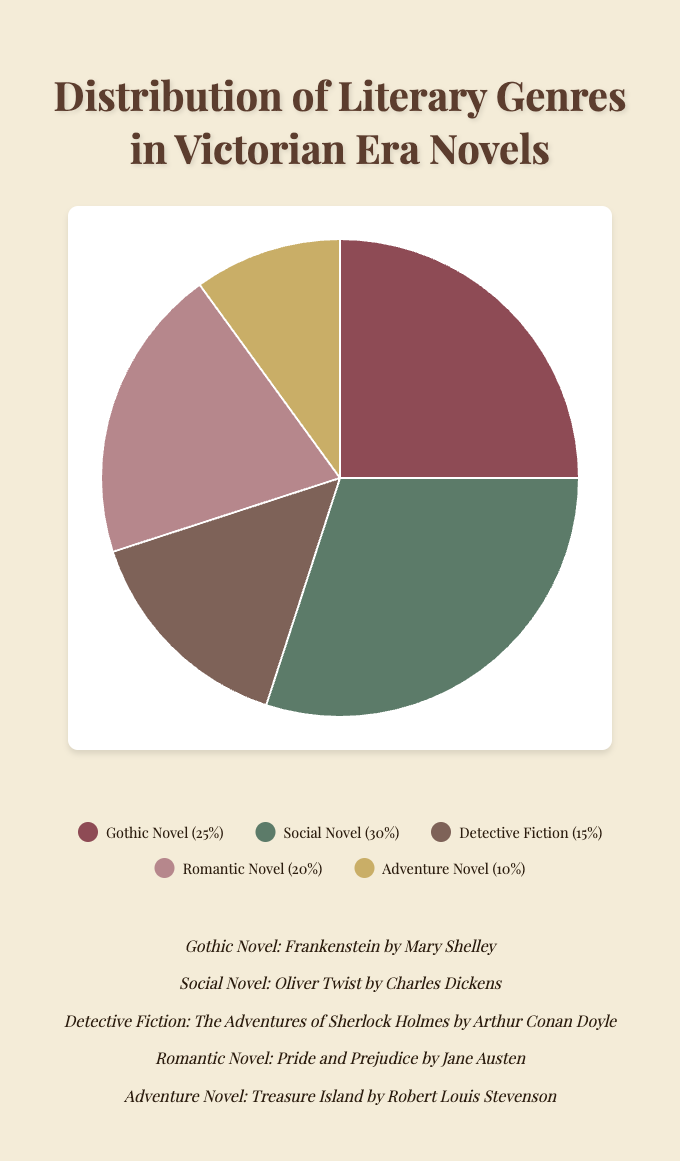What's the most predominant literary genre in the Victorian era according to the chart? Inspecting the pie chart, the largest slice corresponds to the Social Novel, indicating it is the most predominant genre.
Answer: Social Novel Which genre has the smallest representation in the chart, and what percentage does it hold? The smallest section of the pie chart represents the Adventure Novel, holding 10%.
Answer: Adventure Novel, 10% Combine the percentages of Gothic and Romantic Novels. What do they sum to? Adding the percentage of the Gothic Novel (25%) and the Romantic Novel (20%) results in 45%.
Answer: 45% How much greater is the representation of Social Novels compared to Detective Fiction? The Social Novel constitutes 30%, while Detective Fiction is at 15%. The difference can be calculated as 30% - 15% = 15%.
Answer: 15% Rank the genres from most to least represented according to the chart. From most to least: Social Novel (30%), Gothic Novel (25%), Romantic Novel (20%), Detective Fiction (15%), Adventure Novel (10%).
Answer: Social Novel, Gothic Novel, Romantic Novel, Detective Fiction, Adventure Novel Analyze the visual segment for Detective Fiction. What color is it represented by? According to the legend, Detective Fiction is represented by the color grayish-brown on the pie chart.
Answer: grayish-brown What percentage of the genres are comprised of Adventure and Detective Fiction together? Summing up the Adventure Novel (10%) and Detective Fiction (15%) results in 25%.
Answer: 25% If the pie chart represents a total of 100 books, how many books would be Gothic Novels? Since Gothic Novel represents 25% of the chart, 25% of 100 books would be 25 books.
Answer: 25 books Compare the representation between the Gothic Novel and the Social Novel. By what fraction is one less or more than the other? The Social Novel (30%) is 5% more than the Gothic Novel (25%). In terms of fraction, it is 5/25 or 1/5 more.
Answer: 1/5 What is the aggregate percentage of genres outside the Social Novel and Gothic Novel? Adding the remaining genres: Detective Fiction (15%), Romantic Novel (20%), and Adventure Novel (10%) gives us 45%.
Answer: 45% 